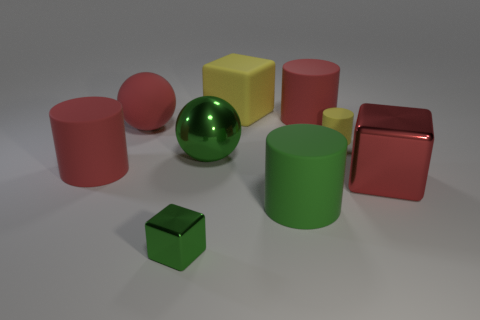Is there anything else that has the same material as the small cube?
Offer a very short reply. Yes. How many things are rubber blocks on the right side of the small green cube or big blue metal cylinders?
Offer a terse response. 1. Are there any tiny metallic cubes that are on the right side of the small object behind the big matte cylinder that is to the left of the big green metallic ball?
Your answer should be compact. No. Are there an equal number of big green matte cylinders and green metallic objects?
Ensure brevity in your answer.  No. What number of gray metallic cylinders are there?
Offer a terse response. 0. What number of things are blocks that are in front of the big metal cube or shiny things to the right of the green ball?
Give a very brief answer. 2. There is a metal object that is behind the red shiny object; is its size the same as the large yellow matte cube?
Provide a succinct answer. Yes. There is a yellow object that is the same shape as the green rubber object; what size is it?
Keep it short and to the point. Small. There is another block that is the same size as the yellow block; what is it made of?
Offer a very short reply. Metal. What material is the red thing that is the same shape as the big green shiny object?
Provide a succinct answer. Rubber. 